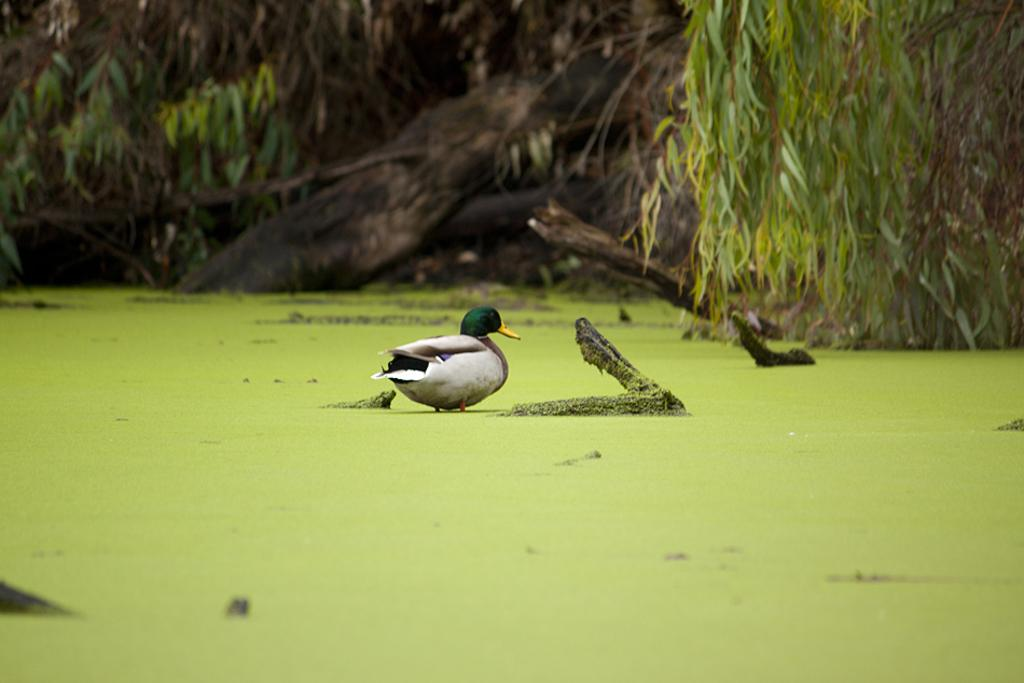What type of animal is in the image? There is a bird in the image. What colors can be seen on the bird? The bird has green and gray colors. What is the bird standing on? The bird is standing on a green surface. What can be seen in the background of the image? The background of the image includes trees. What color are the trees in the image? The trees have green colors. What flavor of ice cream does the bird prefer in the image? There is no mention of ice cream or any preference for flavor in the image. 